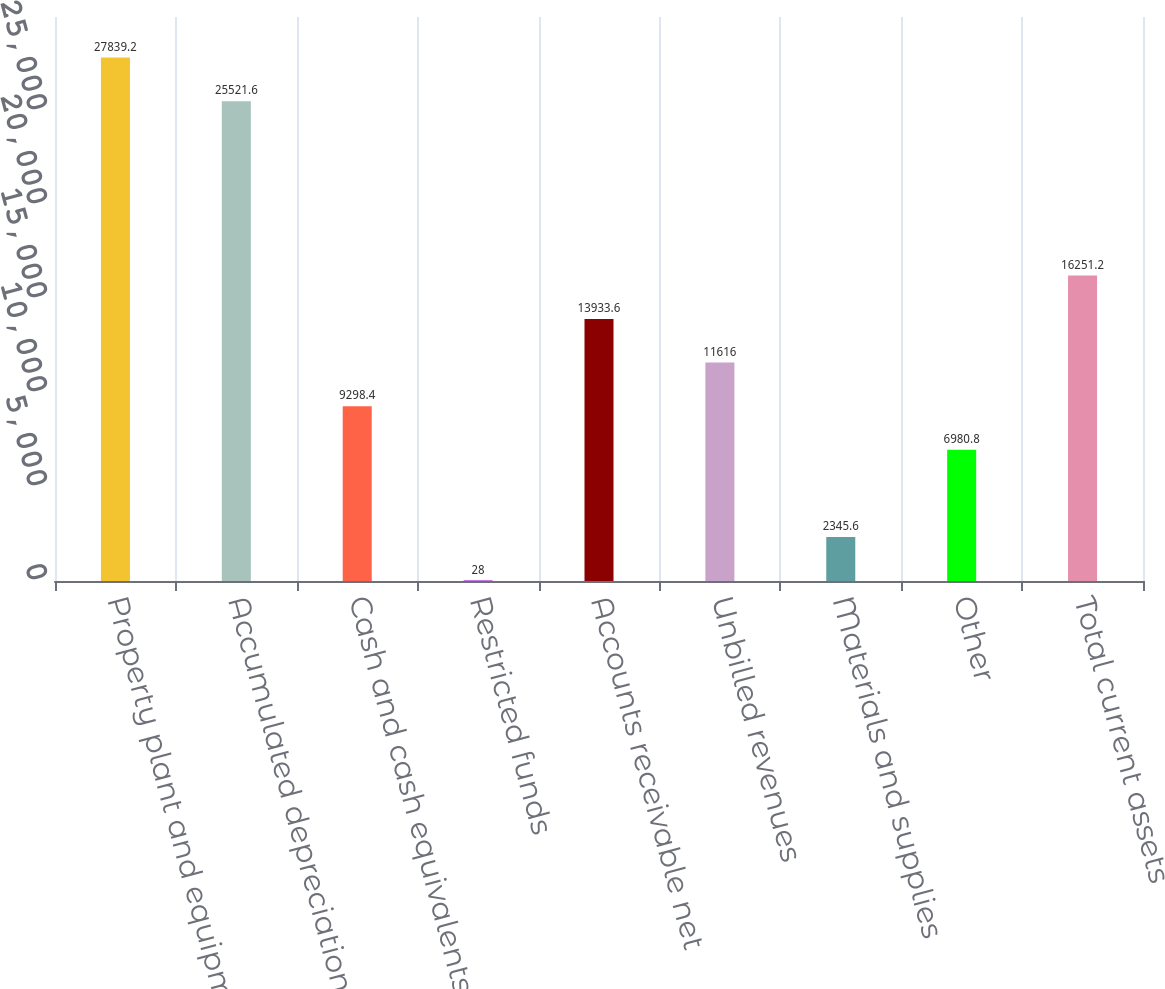Convert chart to OTSL. <chart><loc_0><loc_0><loc_500><loc_500><bar_chart><fcel>Property plant and equipment<fcel>Accumulated depreciation<fcel>Cash and cash equivalents<fcel>Restricted funds<fcel>Accounts receivable net<fcel>Unbilled revenues<fcel>Materials and supplies<fcel>Other<fcel>Total current assets<nl><fcel>27839.2<fcel>25521.6<fcel>9298.4<fcel>28<fcel>13933.6<fcel>11616<fcel>2345.6<fcel>6980.8<fcel>16251.2<nl></chart> 